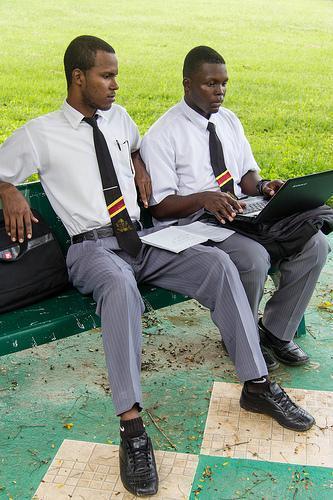How many men are pictured?
Give a very brief answer. 2. 